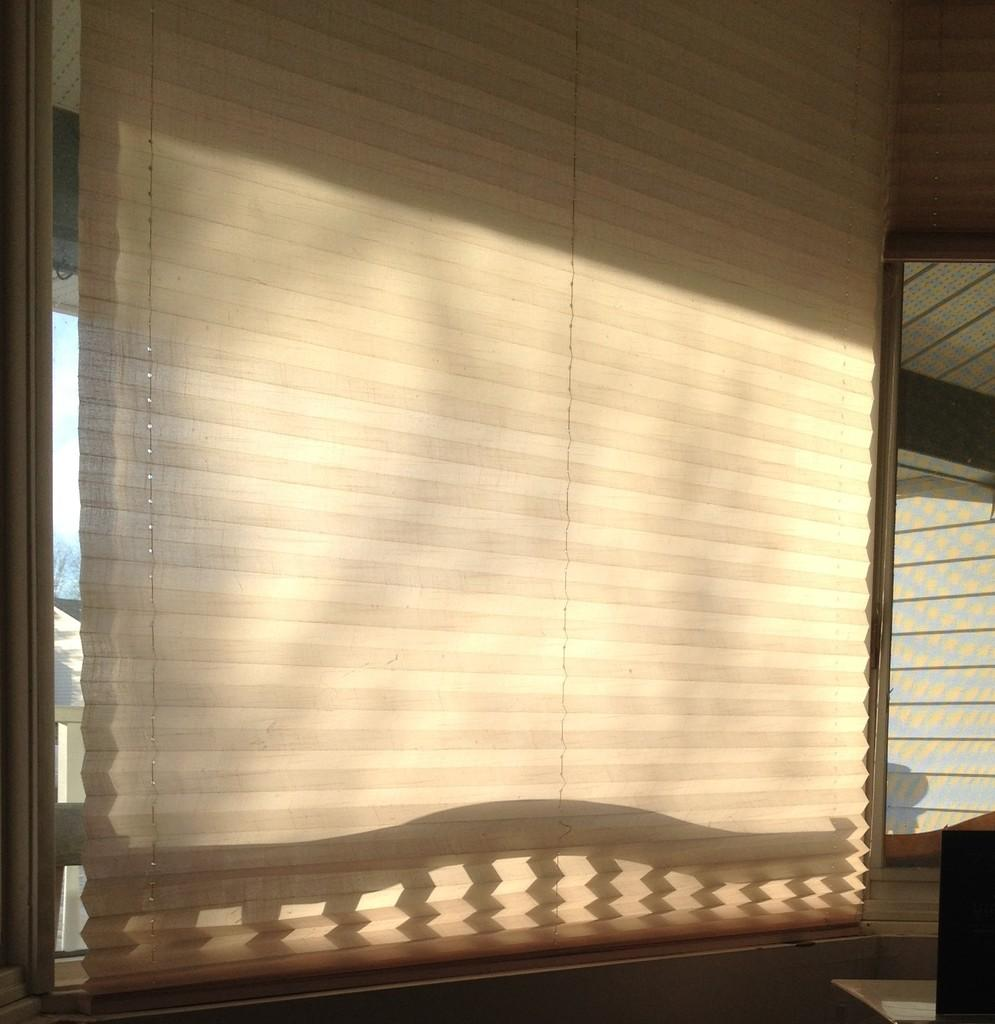What type of window coverings are present in the image? There are curtains on the windows in the image. Can you describe the object in the image? Unfortunately, the provided facts do not give enough information to describe the object in the image. What type of twig is being used to knit a scarf in the image? There is no twig or knitting activity present in the image. What color is the yarn being used to weave a basket in the image? There is no yarn or weaving activity present in the image. 